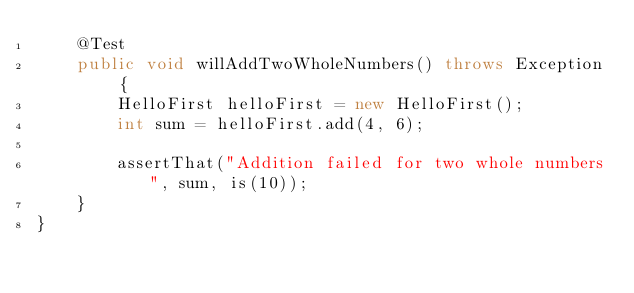<code> <loc_0><loc_0><loc_500><loc_500><_Java_>    @Test
    public void willAddTwoWholeNumbers() throws Exception {
        HelloFirst helloFirst = new HelloFirst();
        int sum = helloFirst.add(4, 6);

        assertThat("Addition failed for two whole numbers", sum, is(10));
    }
}</code> 